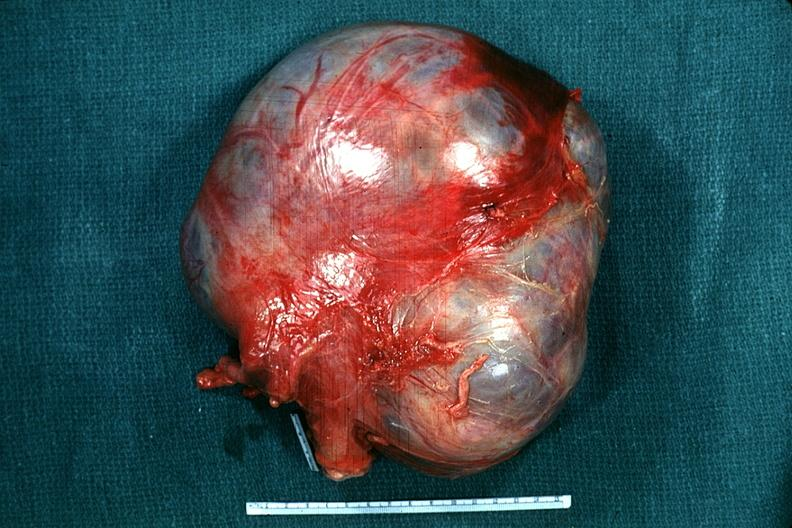s mucinous cystadenocarcinoma present?
Answer the question using a single word or phrase. Yes 